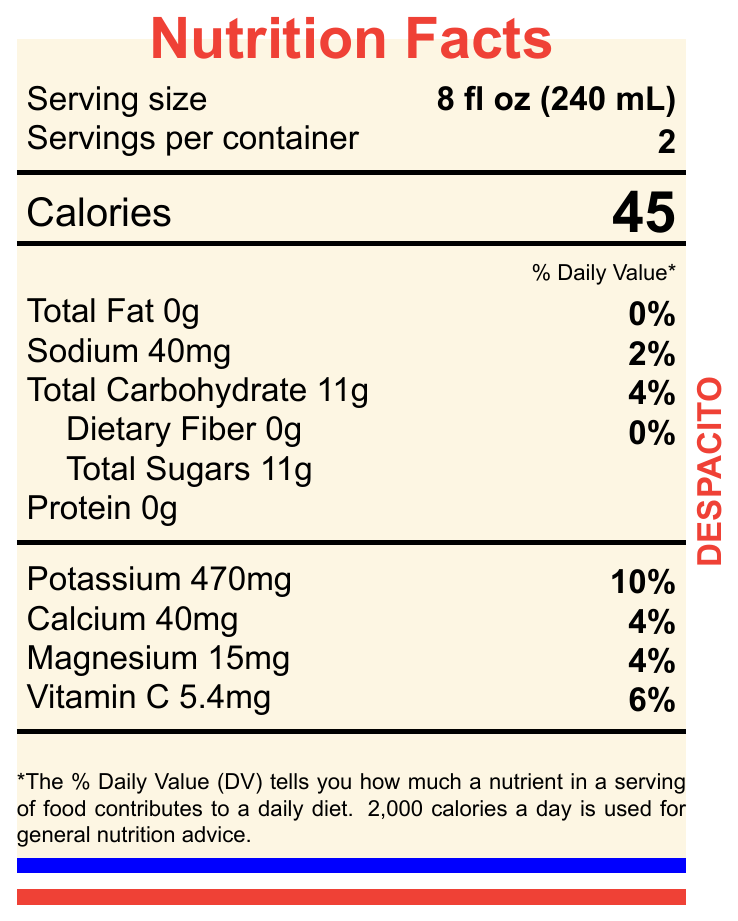what is the serving size? The serving size is clearly listed in the document as 8 fl oz (240 mL).
Answer: 8 fl oz (240 mL) how many servings per container? The document states that there are 2 servings per container.
Answer: 2 how many calories per serving? The document indicates that each serving contains 45 calories.
Answer: 45 calories what is the amount of potassium per serving? The potassium content per serving is specified as 470mg in the document.
Answer: 470mg does the product contain any dietary fiber? According to the document, the product contains 0g of dietary fiber.
Answer: No what is the daily value percentage of sodium? The daily value percentage for sodium is given as 2%.
Answer: 2% how much calcium is in one serving of this product? The document lists 40mg of calcium per serving.
Answer: 40mg what is the main ingredient of Despacito Coconut Water? The ingredient section of the document lists "100% Pure Coconut Water" as the main ingredient.
Answer: 100% Pure Coconut Water multiple-choice
The product is branded with which of the following color schemes?
A. Jamaican flag colors
B. Puerto Rican flag colors
C. Brazilian flag colors The document mentions that the packaging is marked with Puerto Rican flag colors.
Answer: B multiple-choice
What are some features of the Despacito Coconut Water brand?
i. No added sugars or preservatives
ii. Sourced from Jamaican coconuts
iii. Inspired by Daddy Yankee's hit song 'Despacito'
iv. Enhanced with artificial flavors The listed features in the document include "No added sugars or preservatives" and "Inspired by Daddy Yankee's hit song 'Despacito'" and do not mention Jamaican coconuts or artificial flavors.
Answer: D. i and iii yes/no
Is this product USDA Organic certified? The document indicates that the product is USDA Organic certified.
Answer: Yes summary
summarize the key nutritional and branding details provided in the document The document provides a detailed breakdown of the nutritional content per serving, lists important brand features inspired by "Despacito," certification details, and packaging information.
Answer: Despacito Coconut Water has a serving size of 8 fl oz (240 mL) with 2 servings per container. Each serving contains 45 calories, 0g total fat, 40mg sodium (2% DV), 11g total carbohydrate (4% DV) including 11g total sugars, 0g protein, 470mg potassium (10% DV), 40mg calcium (4% DV), 15mg magnesium (4% DV), and 5.4mg vitamin C (6% DV). The product consists of 100% pure coconut water, is non-GMO, USDA Organic certified, and produced without added sugars or preservatives. It is inspired by Daddy Yankee's hit song 'Despacito' and sourced from Puerto Rican coconuts. It comes in recyclable bottles with Puerto Rican flag colors. who is the distributor of this product? The document specifies that the distributor is Yankee Records Drinks Division.
Answer: Yankee Records Drinks Division where are the coconuts sourced from for this product? The document states that the coconuts are sourced from Puerto Rico.
Answer: Puerto Rico what is the barcode for this product? The barcode listed in the document is 896745231098.
Answer: 896745231098 When is the product best before? The best before date is not visually shown in the document; it indicates to see the top of the bottle for this information.
Answer: Not indicated in the document does this product contain protein? The document states that each serving contains 0g of protein.
Answer: No 